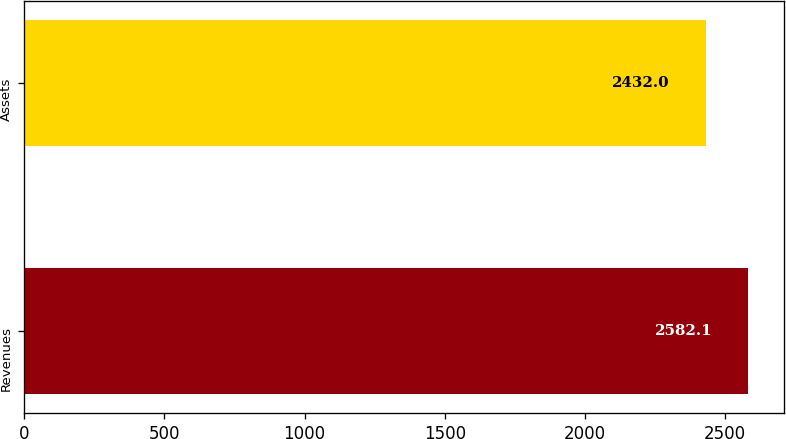Convert chart to OTSL. <chart><loc_0><loc_0><loc_500><loc_500><bar_chart><fcel>Revenues<fcel>Assets<nl><fcel>2582.1<fcel>2432<nl></chart> 